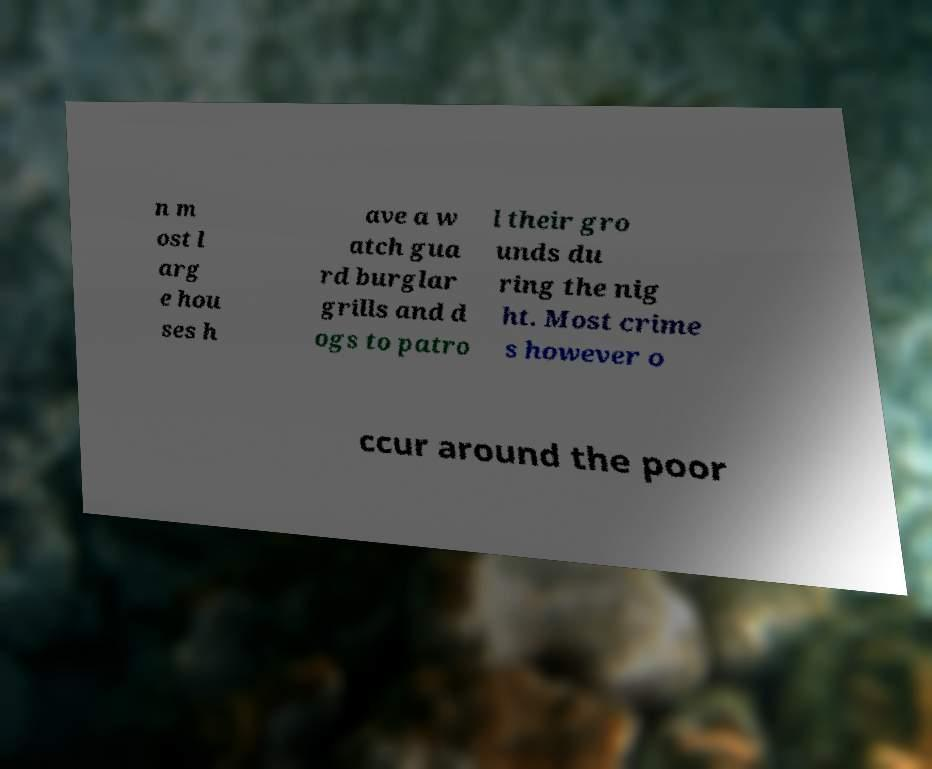What messages or text are displayed in this image? I need them in a readable, typed format. n m ost l arg e hou ses h ave a w atch gua rd burglar grills and d ogs to patro l their gro unds du ring the nig ht. Most crime s however o ccur around the poor 